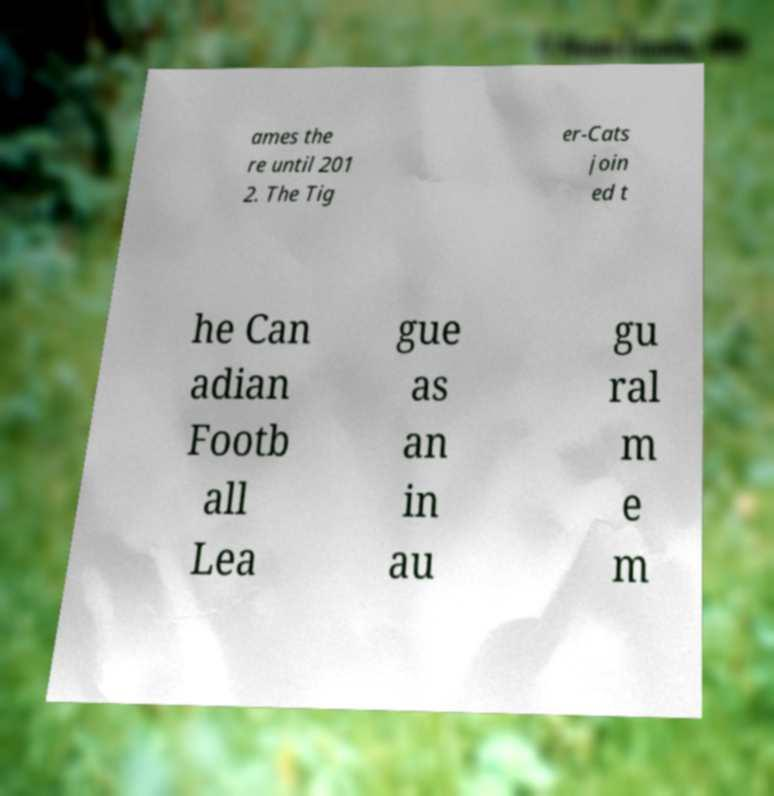There's text embedded in this image that I need extracted. Can you transcribe it verbatim? ames the re until 201 2. The Tig er-Cats join ed t he Can adian Footb all Lea gue as an in au gu ral m e m 